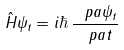<formula> <loc_0><loc_0><loc_500><loc_500>\hat { H } \psi _ { t } = i \hbar { \, } \frac { \ p a \psi _ { t } } { \ p a t }</formula> 